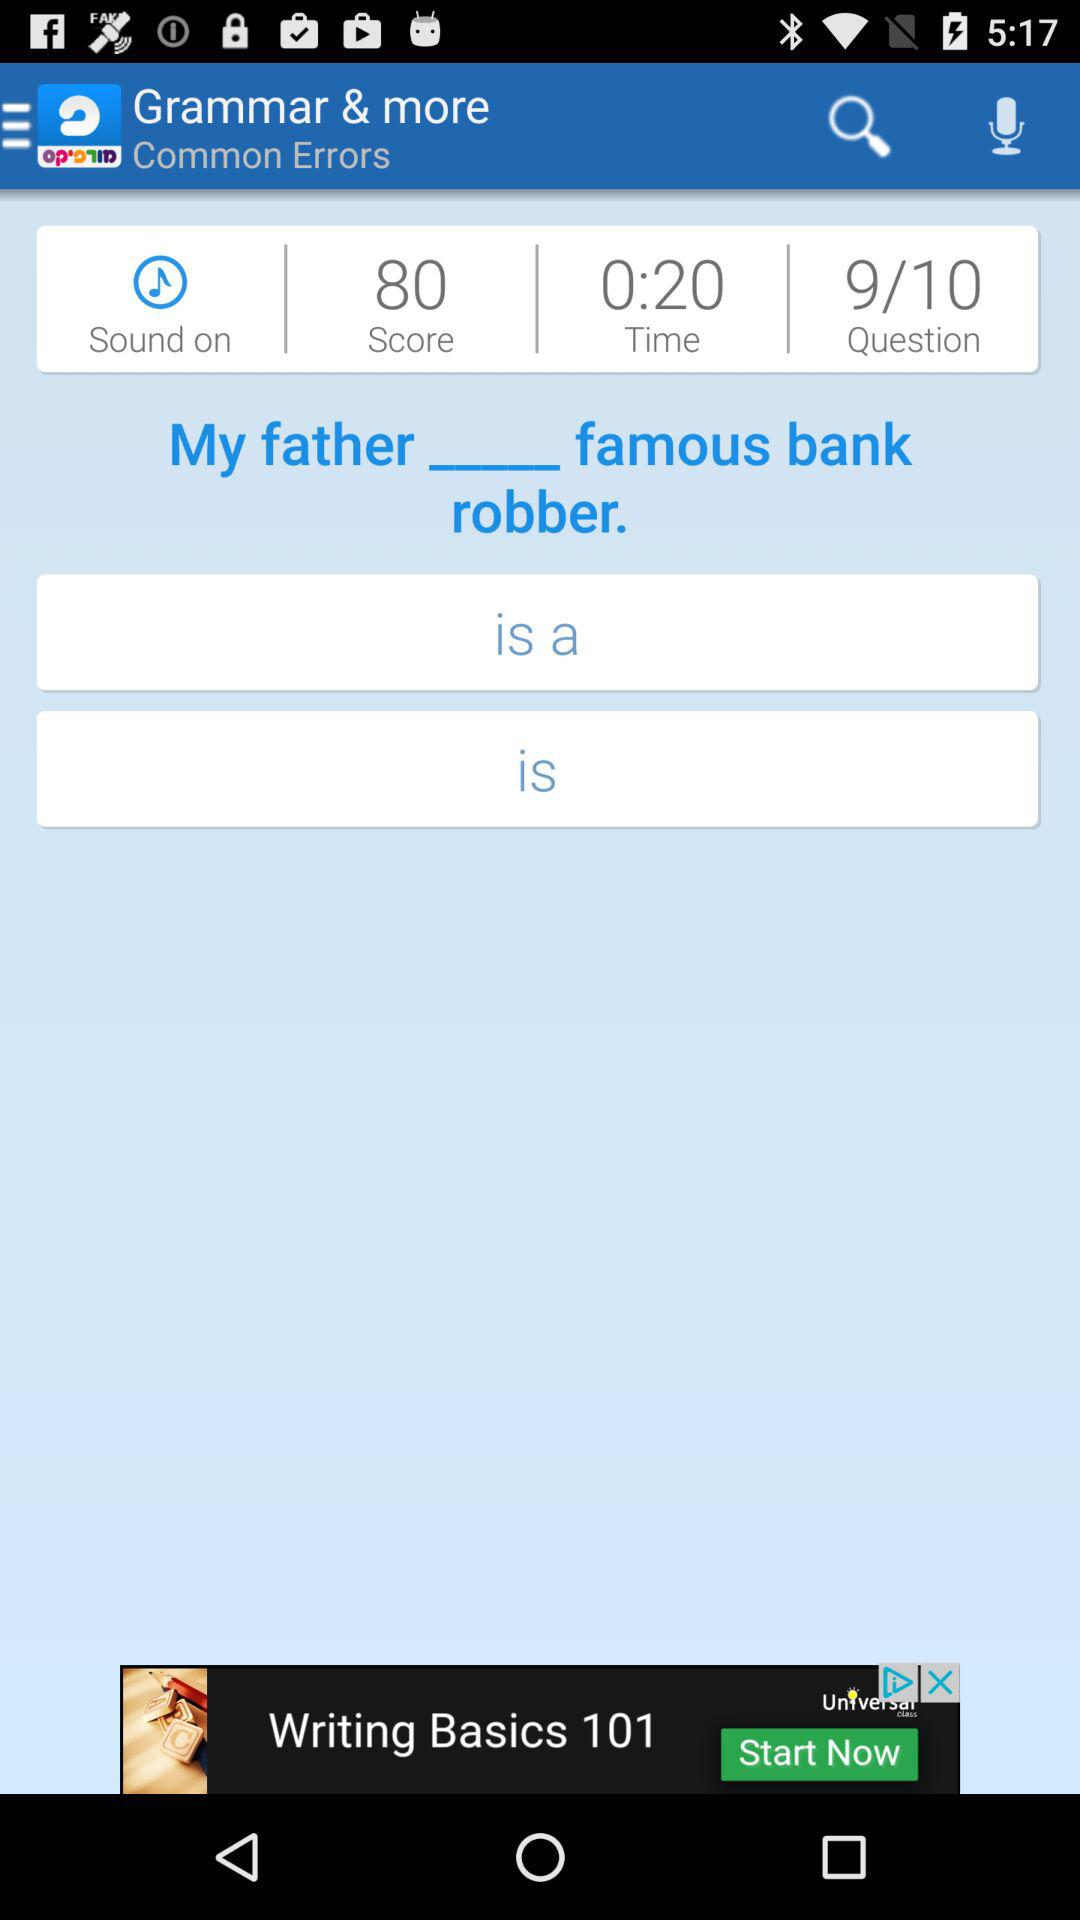How many questions are there in the test? There are 10 questions in the test. 